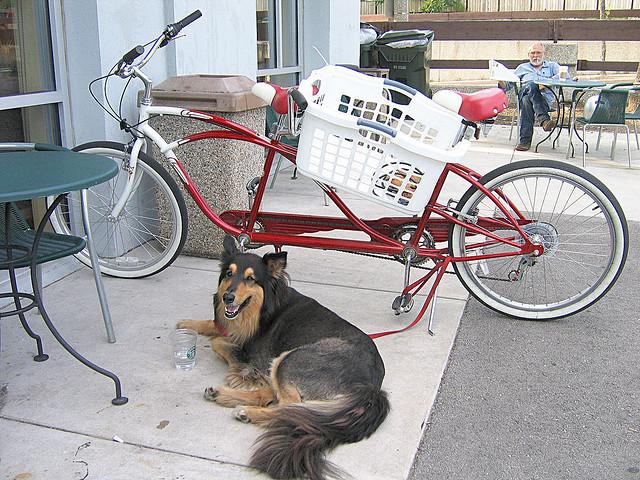What is connected to the bike?
Quick response, please. Basket. Is the dog waiting for someone?
Keep it brief. Yes. Who is the glass of water for?
Concise answer only. Dog. 